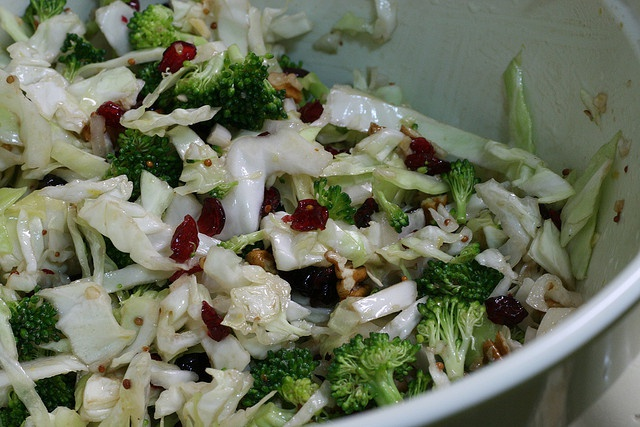Describe the objects in this image and their specific colors. I can see bowl in darkgray, gray, darkgreen, and lavender tones, broccoli in darkgray, black, darkgreen, and olive tones, broccoli in darkgray, black, and darkgreen tones, broccoli in darkgray, black, darkgreen, and gray tones, and broccoli in darkgray, black, and darkgreen tones in this image. 